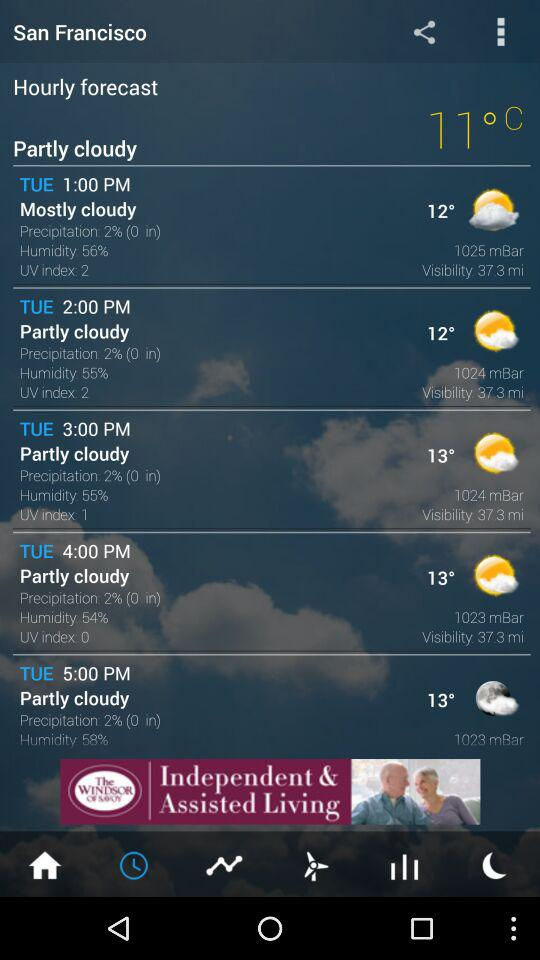What location is given on the screen? The location given on the screen is San Francisco. 